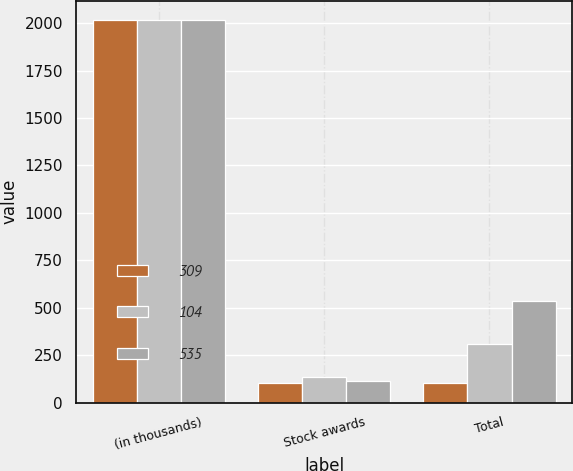<chart> <loc_0><loc_0><loc_500><loc_500><stacked_bar_chart><ecel><fcel>(in thousands)<fcel>Stock awards<fcel>Total<nl><fcel>309<fcel>2017<fcel>104<fcel>104<nl><fcel>104<fcel>2016<fcel>138<fcel>309<nl><fcel>535<fcel>2015<fcel>115<fcel>535<nl></chart> 